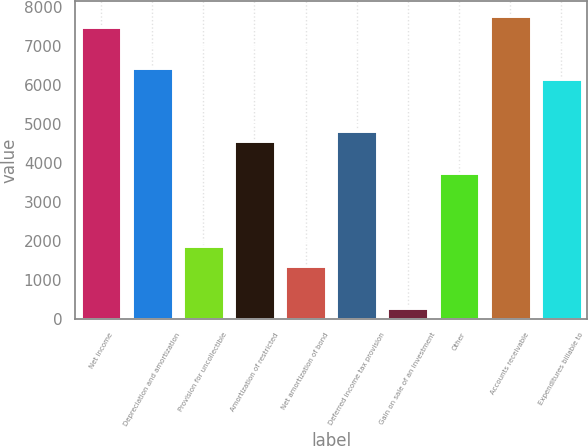Convert chart to OTSL. <chart><loc_0><loc_0><loc_500><loc_500><bar_chart><fcel>Net income<fcel>Depreciation and amortization<fcel>Provision for uncollectible<fcel>Amortization of restricted<fcel>Net amortization of bond<fcel>Deferred income tax provision<fcel>Gain on sale of an investment<fcel>Other<fcel>Accounts receivable<fcel>Expenditures billable to<nl><fcel>7491.6<fcel>6421.4<fcel>1873.05<fcel>4548.55<fcel>1337.95<fcel>4816.1<fcel>267.75<fcel>3745.9<fcel>7759.15<fcel>6153.85<nl></chart> 